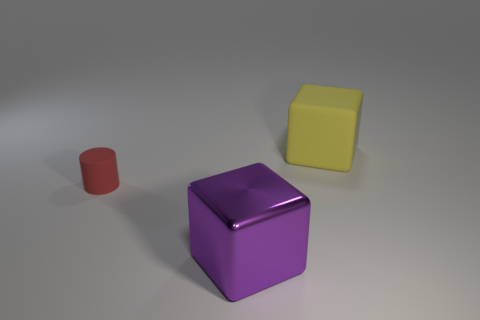Add 2 big purple metallic blocks. How many objects exist? 5 Subtract all purple blocks. How many blocks are left? 1 Subtract all cylinders. How many objects are left? 2 Subtract 1 blocks. How many blocks are left? 1 Subtract all yellow cubes. Subtract all red spheres. How many cubes are left? 1 Subtract all metal cubes. Subtract all small rubber cylinders. How many objects are left? 1 Add 1 yellow objects. How many yellow objects are left? 2 Add 2 tiny cylinders. How many tiny cylinders exist? 3 Subtract 0 brown balls. How many objects are left? 3 